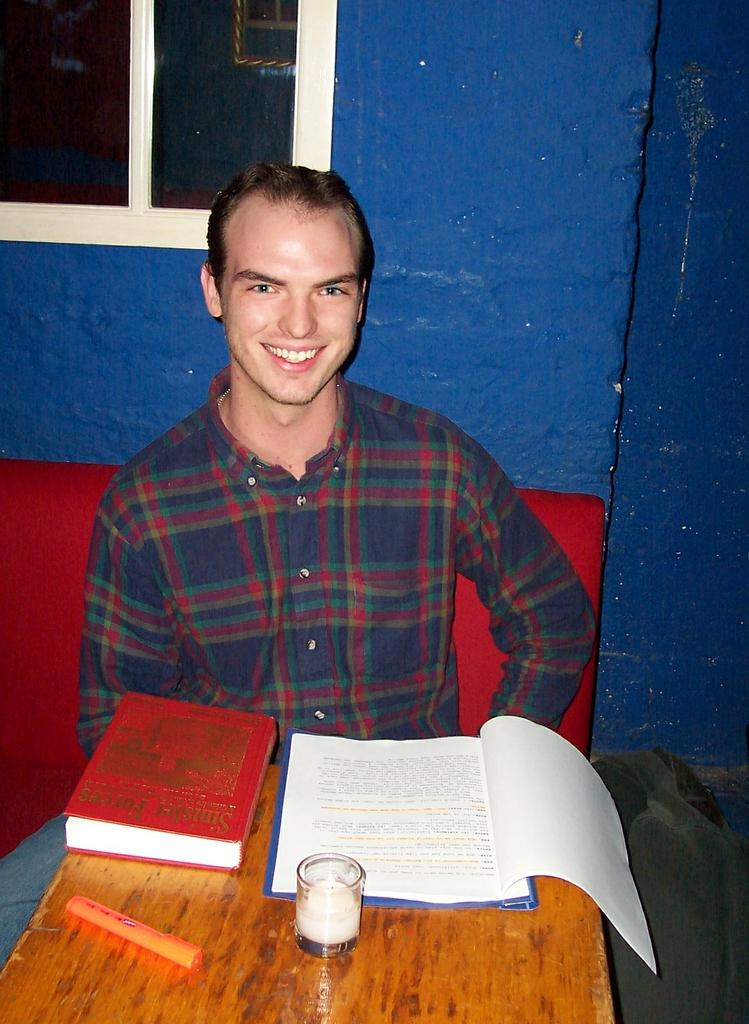What is the guy in the image doing? The guy is sitting on a bench in the image. What is the guy sitting on? There is a bench where the guy is sitting. What is in front of the guy? There is a table in front of the guy. What is on the table? The table consists of books and a glass. What is visible behind the guy? There is a window behind the guy. How does the guy use the screw to make himself more comfortable on the bench? There is no screw present in the image, and therefore it cannot be used to make the guy more comfortable on the bench. 